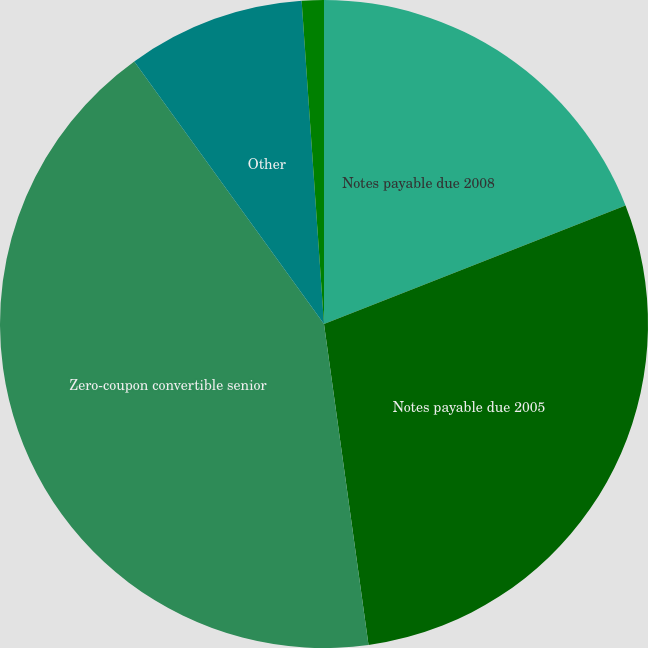Convert chart to OTSL. <chart><loc_0><loc_0><loc_500><loc_500><pie_chart><fcel>Notes payable due 2008<fcel>Notes payable due 2005<fcel>Zero-coupon convertible senior<fcel>Other<fcel>Less-currently payable<nl><fcel>19.04%<fcel>28.77%<fcel>42.24%<fcel>8.86%<fcel>1.1%<nl></chart> 